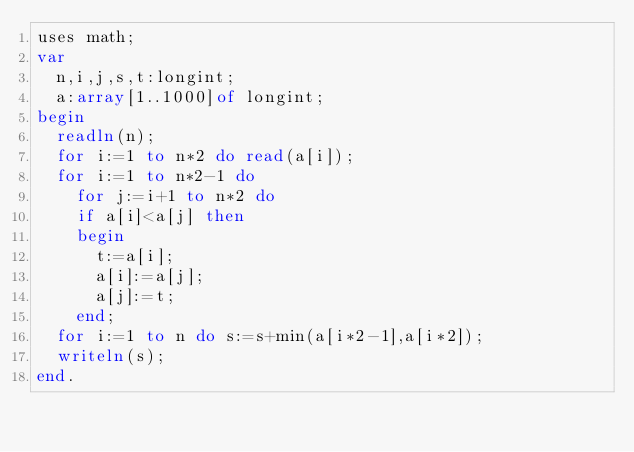Convert code to text. <code><loc_0><loc_0><loc_500><loc_500><_Pascal_>uses math;
var
  n,i,j,s,t:longint;
  a:array[1..1000]of longint;
begin
  readln(n);
  for i:=1 to n*2 do read(a[i]);
  for i:=1 to n*2-1 do
    for j:=i+1 to n*2 do
    if a[i]<a[j] then
    begin
      t:=a[i];
      a[i]:=a[j];
      a[j]:=t;
    end;
  for i:=1 to n do s:=s+min(a[i*2-1],a[i*2]);
  writeln(s);
end.</code> 